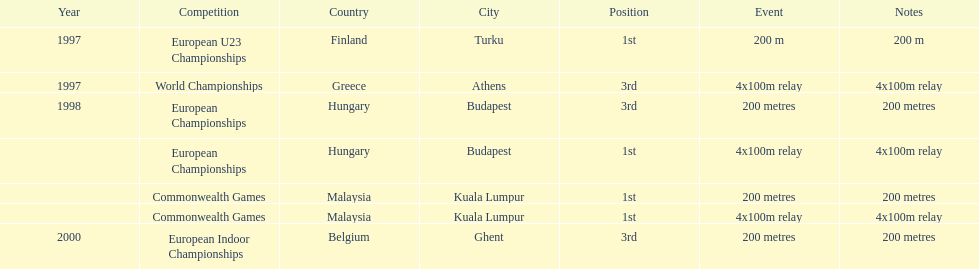How many total years did golding compete? 3. I'm looking to parse the entire table for insights. Could you assist me with that? {'header': ['Year', 'Competition', 'Country', 'City', 'Position', 'Event', 'Notes'], 'rows': [['1997', 'European U23 Championships', 'Finland', 'Turku', '1st', '200 m', '200 m'], ['1997', 'World Championships', 'Greece', 'Athens', '3rd', '4x100m relay', '4x100m relay'], ['1998', 'European Championships', 'Hungary', 'Budapest', '3rd', '200 metres', '200 metres'], ['', 'European Championships', 'Hungary', 'Budapest', '1st', '4x100m relay', '4x100m relay'], ['', 'Commonwealth Games', 'Malaysia', 'Kuala Lumpur', '1st', '200 metres', '200 metres'], ['', 'Commonwealth Games', 'Malaysia', 'Kuala Lumpur', '1st', '4x100m relay', '4x100m relay'], ['2000', 'European Indoor Championships', 'Belgium', 'Ghent', '3rd', '200 metres', '200 metres']]} 